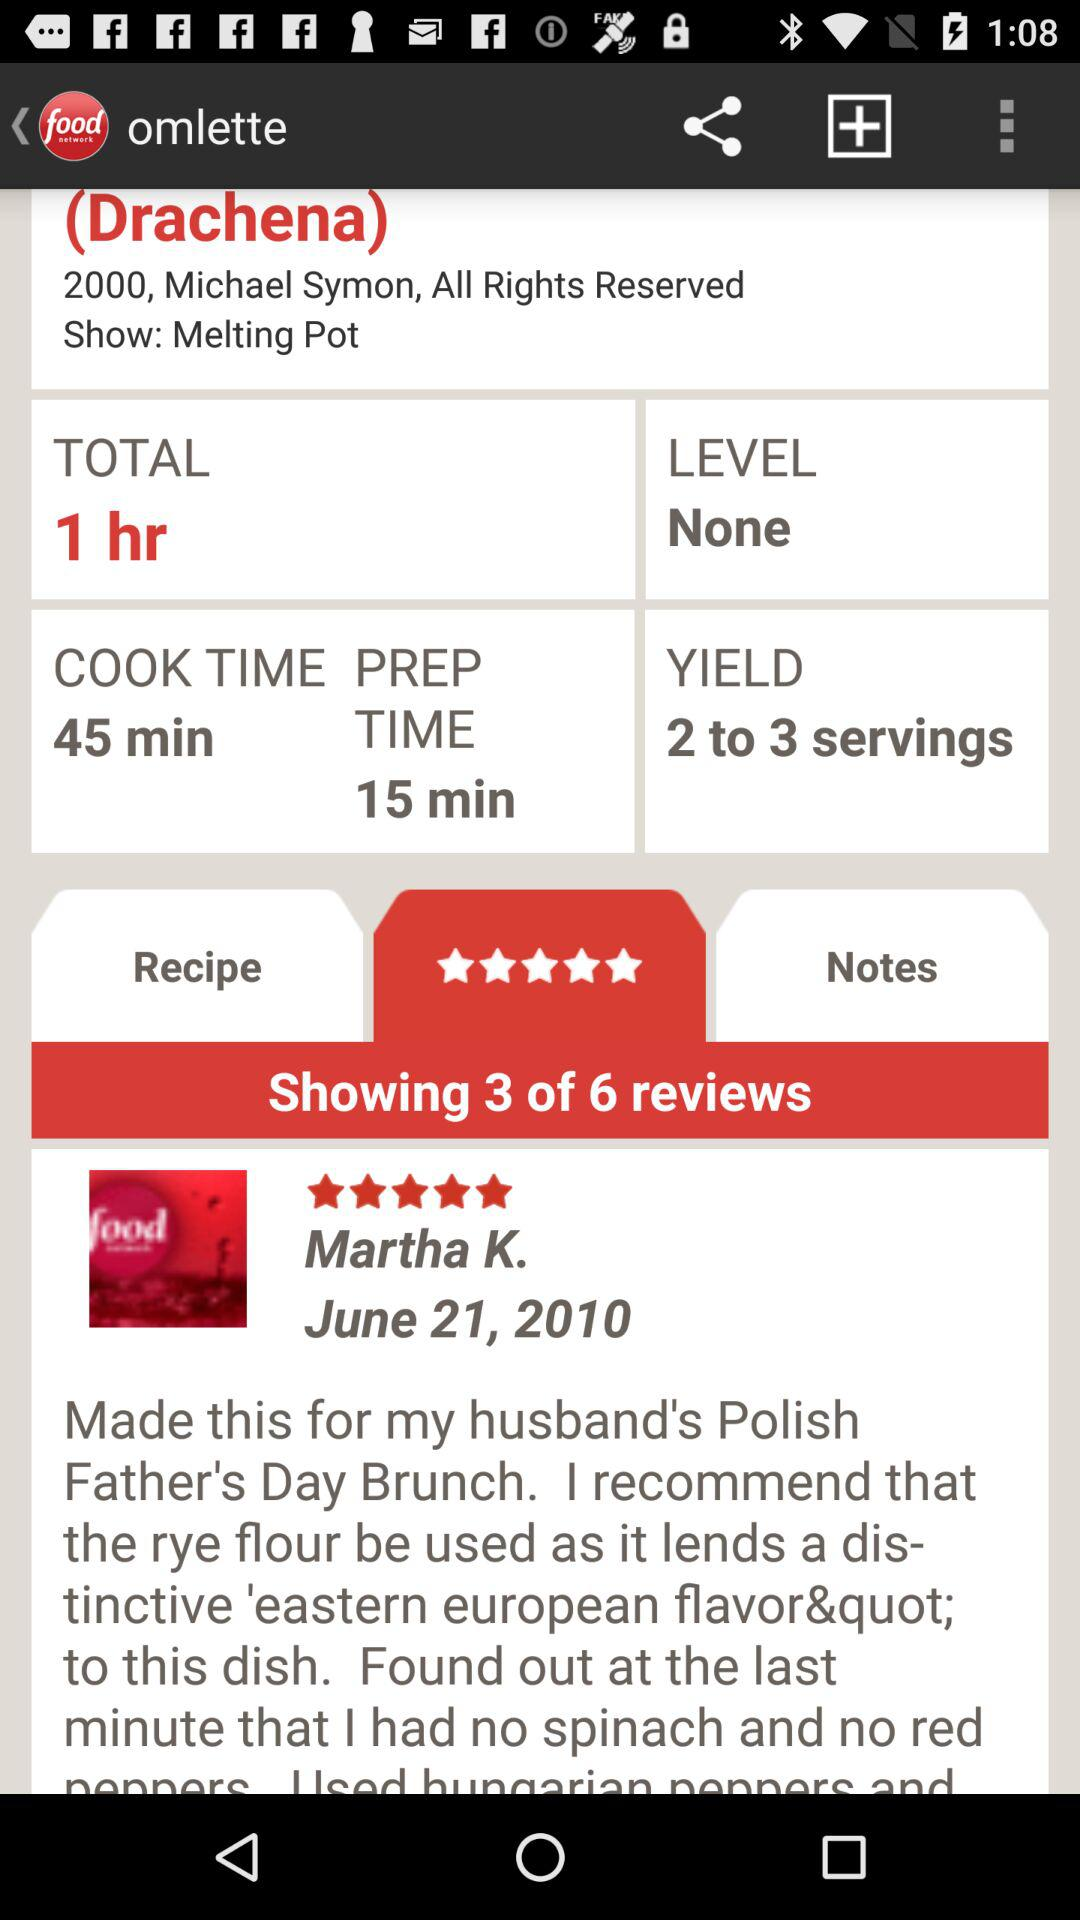How many reviews in total are there? There are 6 reviews in total. 